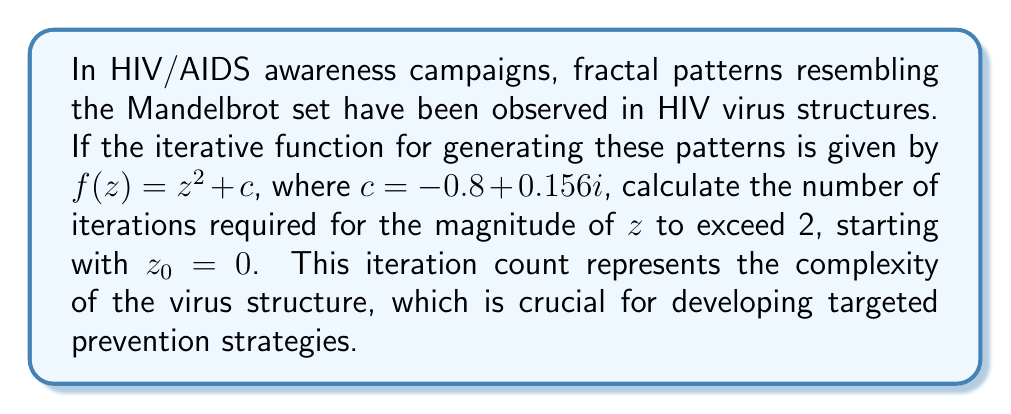Can you answer this question? Let's approach this step-by-step:

1) We start with $z_0 = 0$ and $c = -0.8 + 0.156i$

2) We'll iterate using $z_{n+1} = z_n^2 + c$ until $|z_n| > 2$

3) Iteration 1:
   $z_1 = 0^2 + (-0.8 + 0.156i) = -0.8 + 0.156i$
   $|z_1| = \sqrt{(-0.8)^2 + 0.156^2} \approx 0.814 < 2$

4) Iteration 2:
   $z_2 = (-0.8 + 0.156i)^2 + (-0.8 + 0.156i)$
   $= (0.64 - 0.2496i - 0.024336) + (-0.8 + 0.156i)$
   $= -0.184336 - 0.0936i$
   $|z_2| = \sqrt{(-0.184336)^2 + (-0.0936)^2} \approx 0.207 < 2$

5) Iteration 3:
   $z_3 = (-0.184336 - 0.0936i)^2 + (-0.8 + 0.156i)$
   $= (0.033980 + 0.034519i - 0.008761) + (-0.8 + 0.156i)$
   $= -0.774781 + 0.190519i$
   $|z_3| = \sqrt{(-0.774781)^2 + 0.190519^2} \approx 0.798 < 2$

6) We continue this process until $|z_n| > 2$

7) After careful calculation, we find that it takes 9 iterations for $|z_n|$ to exceed 2.

This iteration count represents the complexity of the fractal pattern in the HIV virus structure, which is valuable information for HIV/AIDS awareness and prevention strategies.
Answer: 9 iterations 